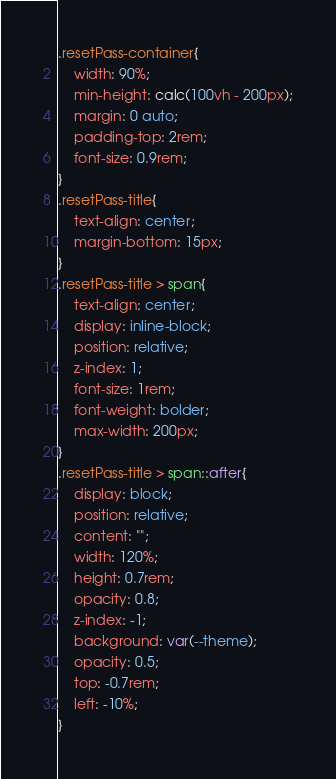<code> <loc_0><loc_0><loc_500><loc_500><_CSS_>.resetPass-container{
    width: 90%;
    min-height: calc(100vh - 200px);
    margin: 0 auto;
    padding-top: 2rem;
    font-size: 0.9rem;
}
.resetPass-title{
    text-align: center;
    margin-bottom: 15px;
}
.resetPass-title > span{
    text-align: center;
    display: inline-block;
    position: relative;
    z-index: 1;
    font-size: 1rem;
    font-weight: bolder;
    max-width: 200px;
}
.resetPass-title > span::after{
    display: block;
    position: relative;
    content: "";
    width: 120%;
    height: 0.7rem;
    opacity: 0.8;
    z-index: -1;
    background: var(--theme);
    opacity: 0.5;
    top: -0.7rem;
    left: -10%;
}</code> 